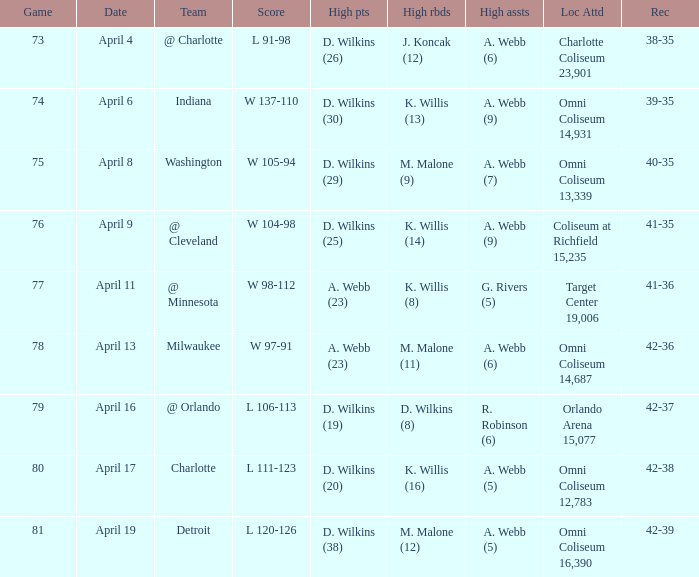How many people had the high points when a. webb (7) had the high assists? 1.0. 